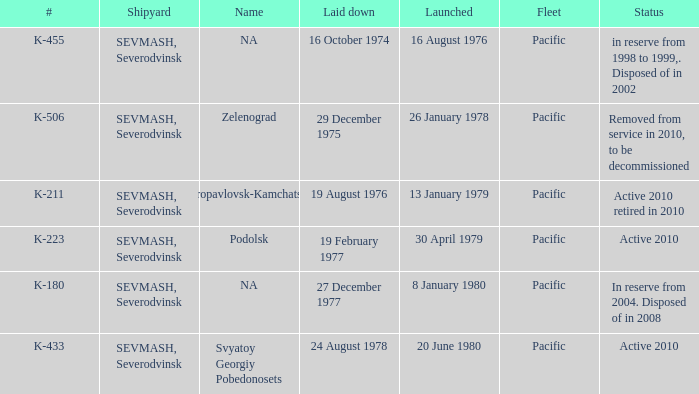What is the status of vessel number K-223? Active 2010. 